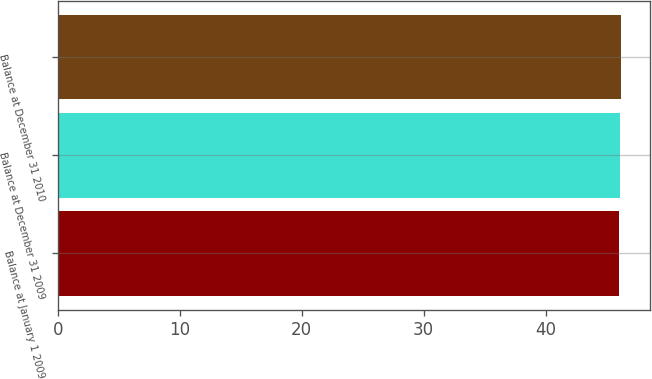Convert chart. <chart><loc_0><loc_0><loc_500><loc_500><bar_chart><fcel>Balance at January 1 2009<fcel>Balance at December 31 2009<fcel>Balance at December 31 2010<nl><fcel>46<fcel>46.1<fcel>46.2<nl></chart> 